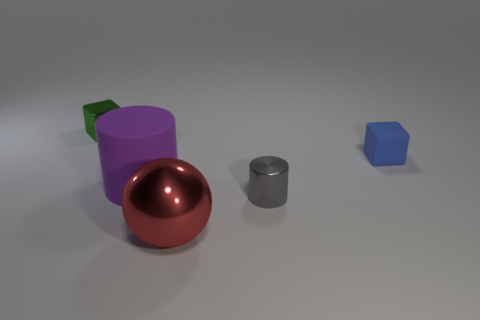Add 5 big yellow things. How many objects exist? 10 Subtract all blocks. How many objects are left? 3 Add 1 tiny green cubes. How many tiny green cubes are left? 2 Add 4 small gray cylinders. How many small gray cylinders exist? 5 Subtract 1 gray cylinders. How many objects are left? 4 Subtract all big gray rubber cylinders. Subtract all cylinders. How many objects are left? 3 